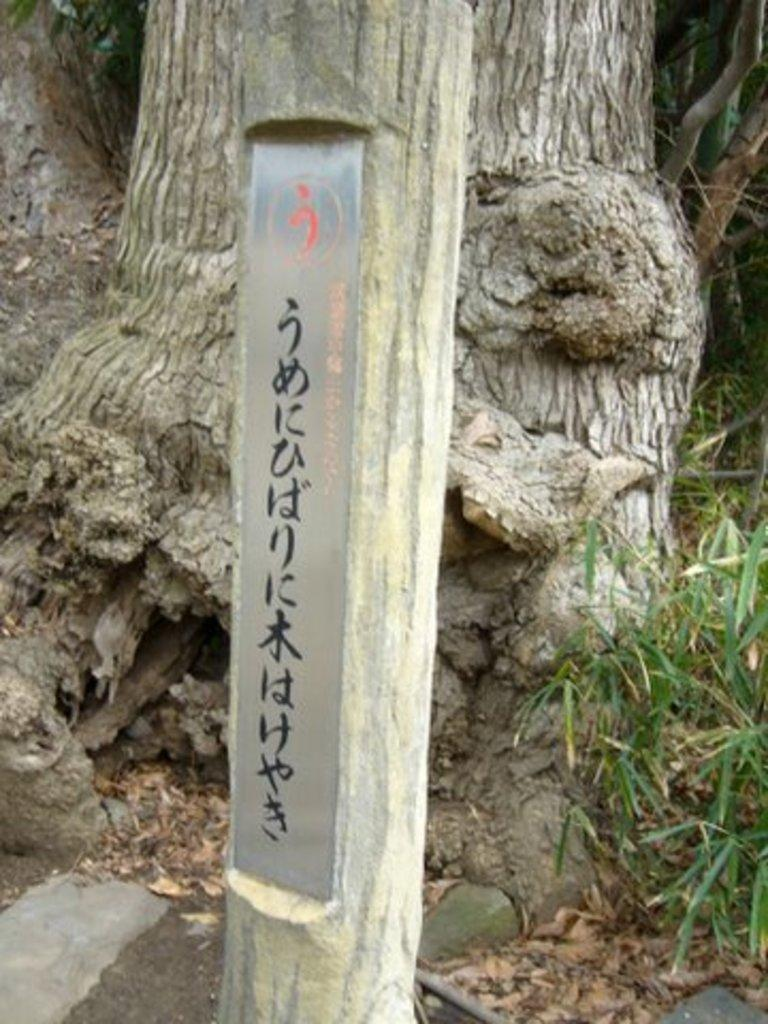What type of vegetation is present in the image? There is a tree and grass in the image. Can you describe the tree in the image? The tree in the image has text written on it. What is the ground covered with in the image? The ground is covered with grass in the image. What type of cloth is draped over the tree in the image? There is no cloth draped over the tree in the image; it only has text written on it. 